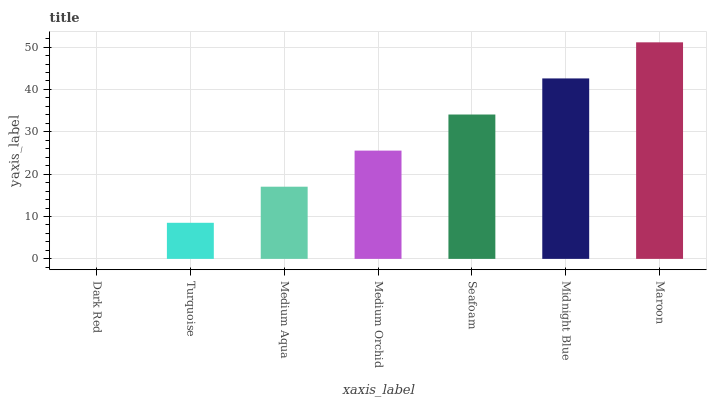Is Dark Red the minimum?
Answer yes or no. Yes. Is Maroon the maximum?
Answer yes or no. Yes. Is Turquoise the minimum?
Answer yes or no. No. Is Turquoise the maximum?
Answer yes or no. No. Is Turquoise greater than Dark Red?
Answer yes or no. Yes. Is Dark Red less than Turquoise?
Answer yes or no. Yes. Is Dark Red greater than Turquoise?
Answer yes or no. No. Is Turquoise less than Dark Red?
Answer yes or no. No. Is Medium Orchid the high median?
Answer yes or no. Yes. Is Medium Orchid the low median?
Answer yes or no. Yes. Is Dark Red the high median?
Answer yes or no. No. Is Maroon the low median?
Answer yes or no. No. 